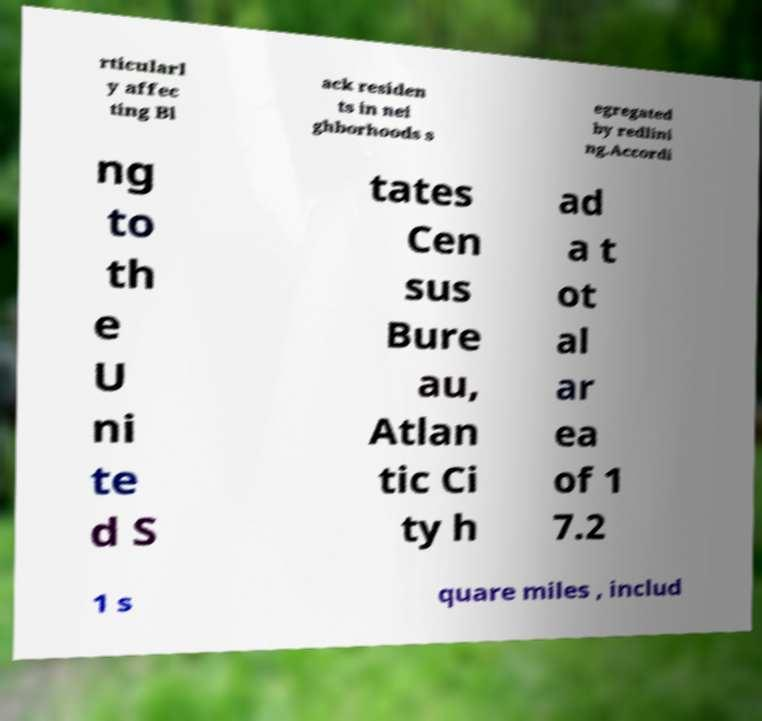What messages or text are displayed in this image? I need them in a readable, typed format. rticularl y affec ting Bl ack residen ts in nei ghborhoods s egregated by redlini ng.Accordi ng to th e U ni te d S tates Cen sus Bure au, Atlan tic Ci ty h ad a t ot al ar ea of 1 7.2 1 s quare miles , includ 